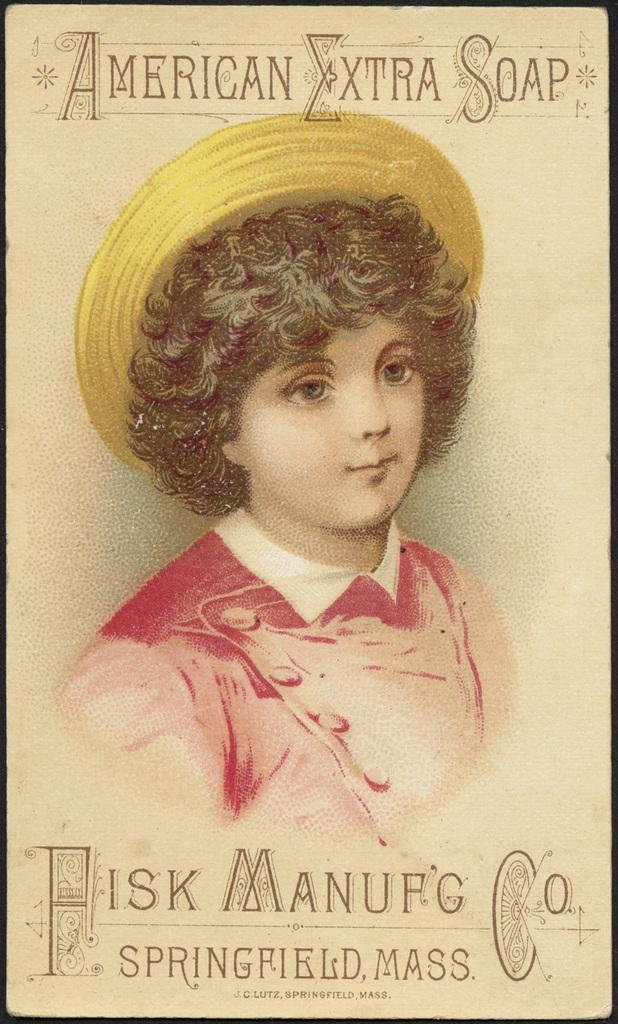What is the main subject of the image? There is an art piece in the image. What does the art piece depict? The art piece depicts a girl. What is the girl wearing in the image? The girl is wearing a cap. What type of plantation can be seen in the background of the image? There is no plantation present in the image; it features an art piece depicting a girl wearing a cap. How much does the girl weigh in the image? The weight of the girl cannot be determined from the image, as it only shows a depiction of her in an art piece. 